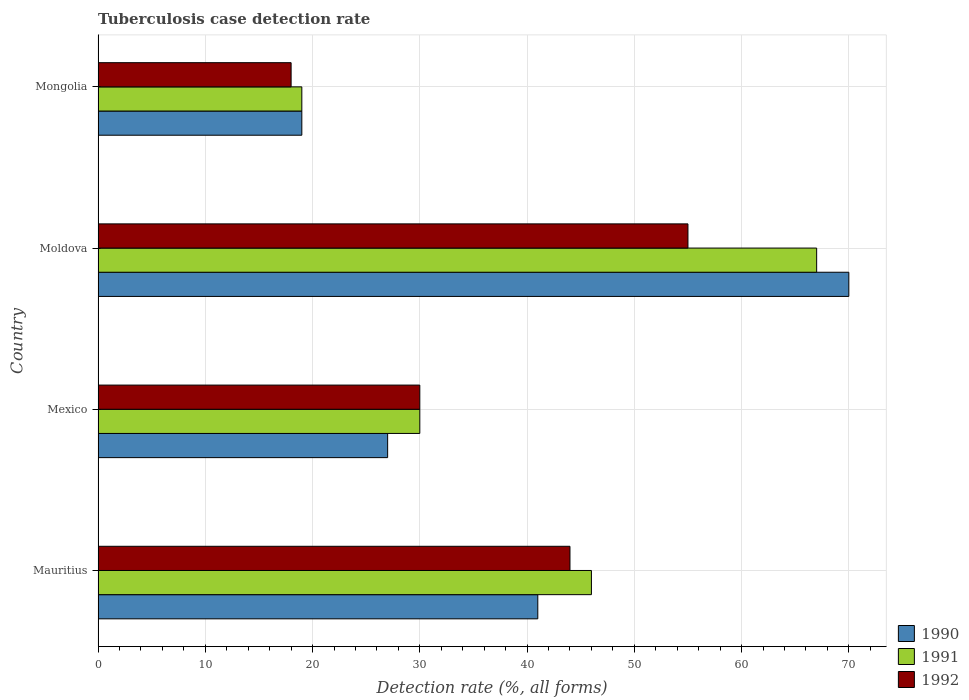How many groups of bars are there?
Make the answer very short. 4. Are the number of bars per tick equal to the number of legend labels?
Keep it short and to the point. Yes. Are the number of bars on each tick of the Y-axis equal?
Offer a terse response. Yes. How many bars are there on the 1st tick from the bottom?
Ensure brevity in your answer.  3. What is the label of the 1st group of bars from the top?
Offer a terse response. Mongolia. What is the tuberculosis case detection rate in in 1990 in Mongolia?
Provide a short and direct response. 19. Across all countries, what is the maximum tuberculosis case detection rate in in 1991?
Your response must be concise. 67. In which country was the tuberculosis case detection rate in in 1992 maximum?
Offer a very short reply. Moldova. In which country was the tuberculosis case detection rate in in 1990 minimum?
Give a very brief answer. Mongolia. What is the total tuberculosis case detection rate in in 1990 in the graph?
Offer a terse response. 157. What is the difference between the tuberculosis case detection rate in in 1992 in Mauritius and the tuberculosis case detection rate in in 1991 in Mexico?
Your answer should be compact. 14. What is the average tuberculosis case detection rate in in 1990 per country?
Provide a succinct answer. 39.25. What is the difference between the tuberculosis case detection rate in in 1992 and tuberculosis case detection rate in in 1990 in Moldova?
Provide a short and direct response. -15. In how many countries, is the tuberculosis case detection rate in in 1991 greater than 42 %?
Provide a short and direct response. 2. What is the ratio of the tuberculosis case detection rate in in 1991 in Moldova to that in Mongolia?
Your answer should be compact. 3.53. Is the tuberculosis case detection rate in in 1992 in Moldova less than that in Mongolia?
Offer a very short reply. No. What is the difference between the highest and the second highest tuberculosis case detection rate in in 1992?
Ensure brevity in your answer.  11. Is the sum of the tuberculosis case detection rate in in 1991 in Mexico and Mongolia greater than the maximum tuberculosis case detection rate in in 1992 across all countries?
Your answer should be very brief. No. What does the 1st bar from the top in Mexico represents?
Make the answer very short. 1992. What does the 1st bar from the bottom in Mexico represents?
Give a very brief answer. 1990. Is it the case that in every country, the sum of the tuberculosis case detection rate in in 1992 and tuberculosis case detection rate in in 1990 is greater than the tuberculosis case detection rate in in 1991?
Your answer should be very brief. Yes. How many countries are there in the graph?
Offer a very short reply. 4. What is the difference between two consecutive major ticks on the X-axis?
Provide a succinct answer. 10. Does the graph contain grids?
Offer a terse response. Yes. What is the title of the graph?
Make the answer very short. Tuberculosis case detection rate. Does "2011" appear as one of the legend labels in the graph?
Keep it short and to the point. No. What is the label or title of the X-axis?
Your answer should be compact. Detection rate (%, all forms). What is the Detection rate (%, all forms) of 1990 in Mauritius?
Give a very brief answer. 41. What is the Detection rate (%, all forms) in 1992 in Mauritius?
Your response must be concise. 44. What is the Detection rate (%, all forms) of 1990 in Mexico?
Give a very brief answer. 27. What is the Detection rate (%, all forms) of 1991 in Mexico?
Offer a terse response. 30. What is the Detection rate (%, all forms) of 1990 in Moldova?
Offer a terse response. 70. What is the Detection rate (%, all forms) in 1992 in Moldova?
Your answer should be very brief. 55. What is the Detection rate (%, all forms) of 1990 in Mongolia?
Offer a very short reply. 19. What is the Detection rate (%, all forms) in 1991 in Mongolia?
Ensure brevity in your answer.  19. What is the Detection rate (%, all forms) in 1992 in Mongolia?
Your answer should be compact. 18. Across all countries, what is the maximum Detection rate (%, all forms) in 1992?
Provide a short and direct response. 55. Across all countries, what is the minimum Detection rate (%, all forms) of 1990?
Your answer should be very brief. 19. Across all countries, what is the minimum Detection rate (%, all forms) of 1991?
Make the answer very short. 19. What is the total Detection rate (%, all forms) in 1990 in the graph?
Offer a terse response. 157. What is the total Detection rate (%, all forms) in 1991 in the graph?
Your answer should be compact. 162. What is the total Detection rate (%, all forms) in 1992 in the graph?
Make the answer very short. 147. What is the difference between the Detection rate (%, all forms) in 1991 in Mauritius and that in Moldova?
Offer a very short reply. -21. What is the difference between the Detection rate (%, all forms) of 1990 in Mauritius and that in Mongolia?
Ensure brevity in your answer.  22. What is the difference between the Detection rate (%, all forms) in 1992 in Mauritius and that in Mongolia?
Provide a short and direct response. 26. What is the difference between the Detection rate (%, all forms) of 1990 in Mexico and that in Moldova?
Your answer should be very brief. -43. What is the difference between the Detection rate (%, all forms) of 1991 in Mexico and that in Moldova?
Provide a short and direct response. -37. What is the difference between the Detection rate (%, all forms) of 1992 in Mexico and that in Moldova?
Make the answer very short. -25. What is the difference between the Detection rate (%, all forms) of 1990 in Mexico and that in Mongolia?
Keep it short and to the point. 8. What is the difference between the Detection rate (%, all forms) of 1992 in Moldova and that in Mongolia?
Make the answer very short. 37. What is the difference between the Detection rate (%, all forms) of 1991 in Mauritius and the Detection rate (%, all forms) of 1992 in Mexico?
Your answer should be compact. 16. What is the difference between the Detection rate (%, all forms) of 1990 in Mauritius and the Detection rate (%, all forms) of 1991 in Moldova?
Provide a succinct answer. -26. What is the difference between the Detection rate (%, all forms) of 1990 in Mauritius and the Detection rate (%, all forms) of 1992 in Moldova?
Ensure brevity in your answer.  -14. What is the difference between the Detection rate (%, all forms) of 1990 in Mauritius and the Detection rate (%, all forms) of 1991 in Mongolia?
Keep it short and to the point. 22. What is the difference between the Detection rate (%, all forms) of 1990 in Mauritius and the Detection rate (%, all forms) of 1992 in Mongolia?
Give a very brief answer. 23. What is the difference between the Detection rate (%, all forms) of 1991 in Mauritius and the Detection rate (%, all forms) of 1992 in Mongolia?
Ensure brevity in your answer.  28. What is the difference between the Detection rate (%, all forms) of 1990 in Mexico and the Detection rate (%, all forms) of 1992 in Moldova?
Offer a very short reply. -28. What is the difference between the Detection rate (%, all forms) of 1990 in Mexico and the Detection rate (%, all forms) of 1991 in Mongolia?
Provide a succinct answer. 8. What is the difference between the Detection rate (%, all forms) of 1990 in Moldova and the Detection rate (%, all forms) of 1991 in Mongolia?
Your answer should be compact. 51. What is the average Detection rate (%, all forms) in 1990 per country?
Your answer should be compact. 39.25. What is the average Detection rate (%, all forms) of 1991 per country?
Provide a short and direct response. 40.5. What is the average Detection rate (%, all forms) of 1992 per country?
Offer a terse response. 36.75. What is the difference between the Detection rate (%, all forms) in 1991 and Detection rate (%, all forms) in 1992 in Mauritius?
Provide a short and direct response. 2. What is the difference between the Detection rate (%, all forms) of 1991 and Detection rate (%, all forms) of 1992 in Mexico?
Ensure brevity in your answer.  0. What is the difference between the Detection rate (%, all forms) in 1990 and Detection rate (%, all forms) in 1991 in Moldova?
Your response must be concise. 3. What is the difference between the Detection rate (%, all forms) in 1990 and Detection rate (%, all forms) in 1992 in Moldova?
Ensure brevity in your answer.  15. What is the difference between the Detection rate (%, all forms) in 1991 and Detection rate (%, all forms) in 1992 in Moldova?
Ensure brevity in your answer.  12. What is the difference between the Detection rate (%, all forms) of 1990 and Detection rate (%, all forms) of 1991 in Mongolia?
Ensure brevity in your answer.  0. What is the ratio of the Detection rate (%, all forms) of 1990 in Mauritius to that in Mexico?
Your answer should be very brief. 1.52. What is the ratio of the Detection rate (%, all forms) of 1991 in Mauritius to that in Mexico?
Offer a terse response. 1.53. What is the ratio of the Detection rate (%, all forms) in 1992 in Mauritius to that in Mexico?
Your response must be concise. 1.47. What is the ratio of the Detection rate (%, all forms) of 1990 in Mauritius to that in Moldova?
Offer a terse response. 0.59. What is the ratio of the Detection rate (%, all forms) in 1991 in Mauritius to that in Moldova?
Offer a very short reply. 0.69. What is the ratio of the Detection rate (%, all forms) in 1990 in Mauritius to that in Mongolia?
Offer a terse response. 2.16. What is the ratio of the Detection rate (%, all forms) of 1991 in Mauritius to that in Mongolia?
Offer a very short reply. 2.42. What is the ratio of the Detection rate (%, all forms) in 1992 in Mauritius to that in Mongolia?
Offer a very short reply. 2.44. What is the ratio of the Detection rate (%, all forms) of 1990 in Mexico to that in Moldova?
Offer a terse response. 0.39. What is the ratio of the Detection rate (%, all forms) in 1991 in Mexico to that in Moldova?
Offer a terse response. 0.45. What is the ratio of the Detection rate (%, all forms) of 1992 in Mexico to that in Moldova?
Offer a terse response. 0.55. What is the ratio of the Detection rate (%, all forms) in 1990 in Mexico to that in Mongolia?
Provide a succinct answer. 1.42. What is the ratio of the Detection rate (%, all forms) in 1991 in Mexico to that in Mongolia?
Your answer should be very brief. 1.58. What is the ratio of the Detection rate (%, all forms) in 1992 in Mexico to that in Mongolia?
Your answer should be compact. 1.67. What is the ratio of the Detection rate (%, all forms) in 1990 in Moldova to that in Mongolia?
Your response must be concise. 3.68. What is the ratio of the Detection rate (%, all forms) of 1991 in Moldova to that in Mongolia?
Ensure brevity in your answer.  3.53. What is the ratio of the Detection rate (%, all forms) in 1992 in Moldova to that in Mongolia?
Give a very brief answer. 3.06. What is the difference between the highest and the lowest Detection rate (%, all forms) in 1991?
Ensure brevity in your answer.  48. What is the difference between the highest and the lowest Detection rate (%, all forms) of 1992?
Your answer should be very brief. 37. 